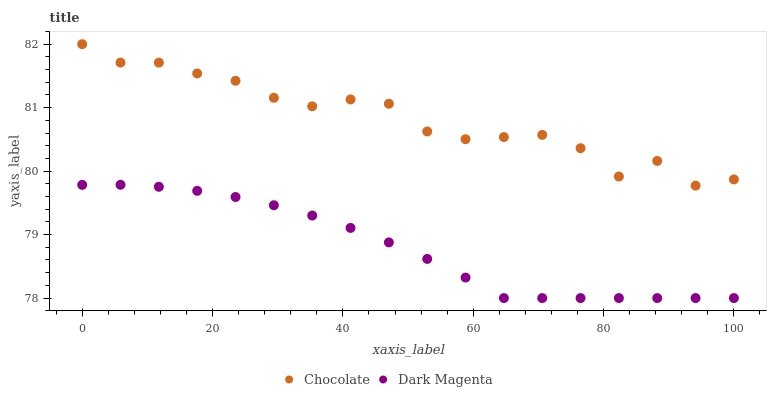Does Dark Magenta have the minimum area under the curve?
Answer yes or no. Yes. Does Chocolate have the maximum area under the curve?
Answer yes or no. Yes. Does Chocolate have the minimum area under the curve?
Answer yes or no. No. Is Dark Magenta the smoothest?
Answer yes or no. Yes. Is Chocolate the roughest?
Answer yes or no. Yes. Is Chocolate the smoothest?
Answer yes or no. No. Does Dark Magenta have the lowest value?
Answer yes or no. Yes. Does Chocolate have the lowest value?
Answer yes or no. No. Does Chocolate have the highest value?
Answer yes or no. Yes. Is Dark Magenta less than Chocolate?
Answer yes or no. Yes. Is Chocolate greater than Dark Magenta?
Answer yes or no. Yes. Does Dark Magenta intersect Chocolate?
Answer yes or no. No. 